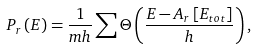<formula> <loc_0><loc_0><loc_500><loc_500>P _ { r } \left ( E \right ) = \frac { 1 } { m h } \sum \Theta \left ( \frac { E - A _ { r } \left [ E _ { t o t } \right ] } { h } \right ) ,</formula> 